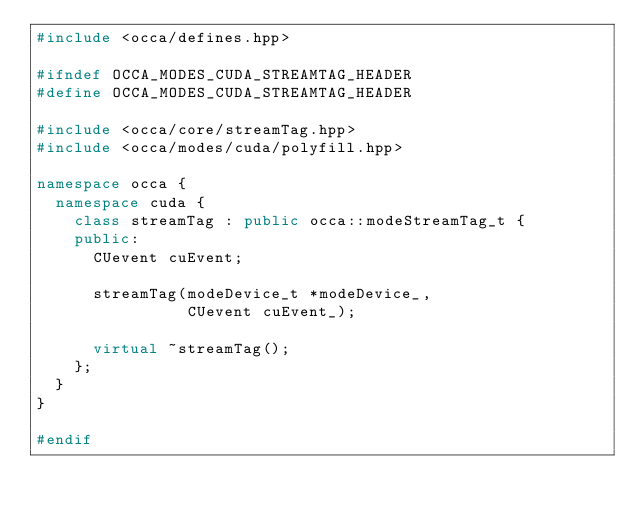<code> <loc_0><loc_0><loc_500><loc_500><_C++_>#include <occa/defines.hpp>

#ifndef OCCA_MODES_CUDA_STREAMTAG_HEADER
#define OCCA_MODES_CUDA_STREAMTAG_HEADER

#include <occa/core/streamTag.hpp>
#include <occa/modes/cuda/polyfill.hpp>

namespace occa {
  namespace cuda {
    class streamTag : public occa::modeStreamTag_t {
    public:
      CUevent cuEvent;

      streamTag(modeDevice_t *modeDevice_,
                CUevent cuEvent_);

      virtual ~streamTag();
    };
  }
}

#endif
</code> 